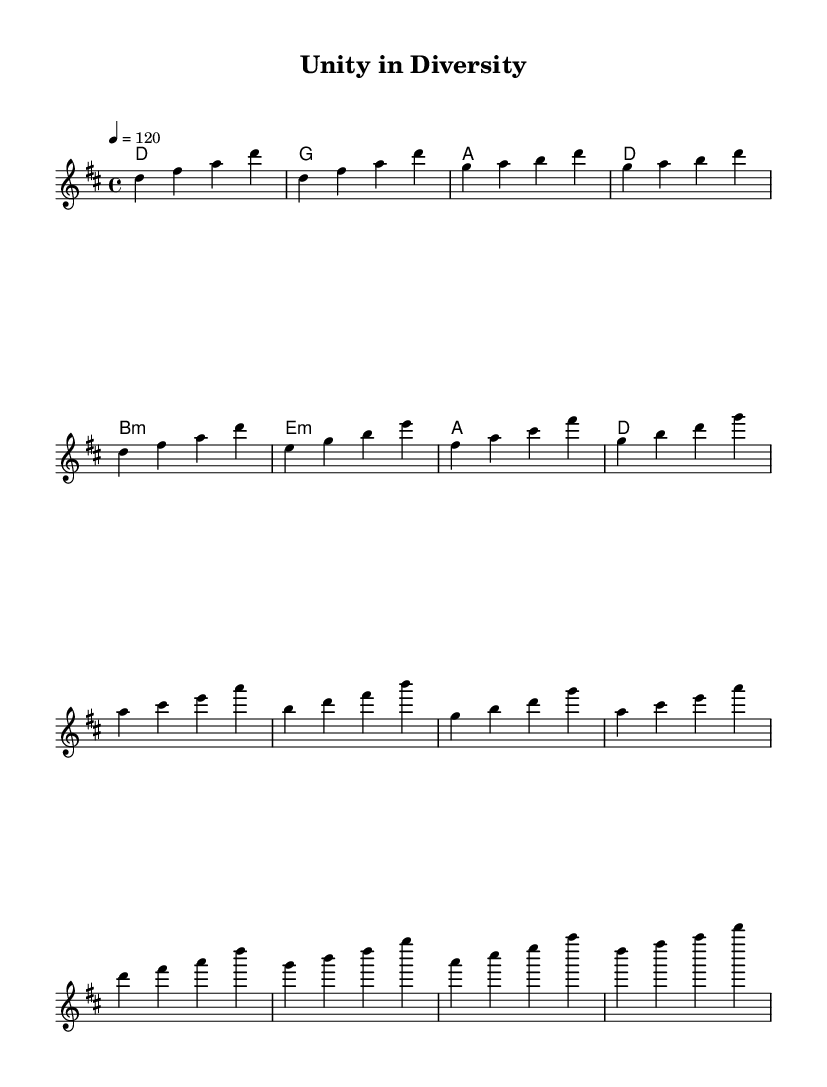What is the key signature of this music? The key signature is indicated at the beginning of the score. The presence of two sharps suggests that this piece is in D major.
Answer: D major What is the time signature of this music? The time signature, located at the beginning of the score, shows that this piece is written in 4/4 time, which means there are four beats in a measure.
Answer: 4/4 What is the tempo marking for this piece? The tempo is indicated at the start of the score with the marking "4 = 120", meaning there are 120 beats per minute with each quarter note receiving one beat.
Answer: 120 How many sections are present in the music? By examining the distinct parts of the sheet music, we can identify that it has four main sections: Intro, Verse, Pre-Chorus, and Chorus, each contributing to the overall structure of the piece.
Answer: Four What type of chords are primarily used in the harmonies? The harmony section indicates that mostly triad chords are used, including major and minor chords, which are characteristic of disco music, particularly in the context of the common I-IV-V patterns.
Answer: Triad chords Which section features the melody starting on A? In the score, the section titled "Pre-Chorus" begins the melody on the note A. This highlights a transitional moment before moving into the Chorus.
Answer: Pre-Chorus What is the first note of the melody? The first note of the melody in the sheet music is D, as seen at the beginning of the "melody" section. This note initiates the piece and sets the tonality.
Answer: D 